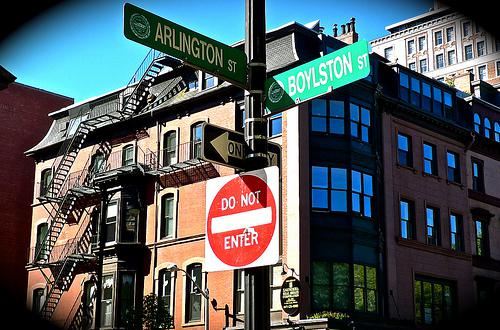Question: what is this a picture of?
Choices:
A. A signpost.
B. Computer.
C. Wheelbarrow.
D. Baby.
Answer with the letter. Answer: A Question: what does the red sign say?
Choices:
A. Stop.
B. Toxic.
C. Read Me.
D. Do not enter.
Answer with the letter. Answer: D Question: why is there a do not enter sign?
Choices:
A. Because it is a one way street.
B. To prevent access.
C. So people can see.
D. So people can know not to enter.
Answer with the letter. Answer: A 